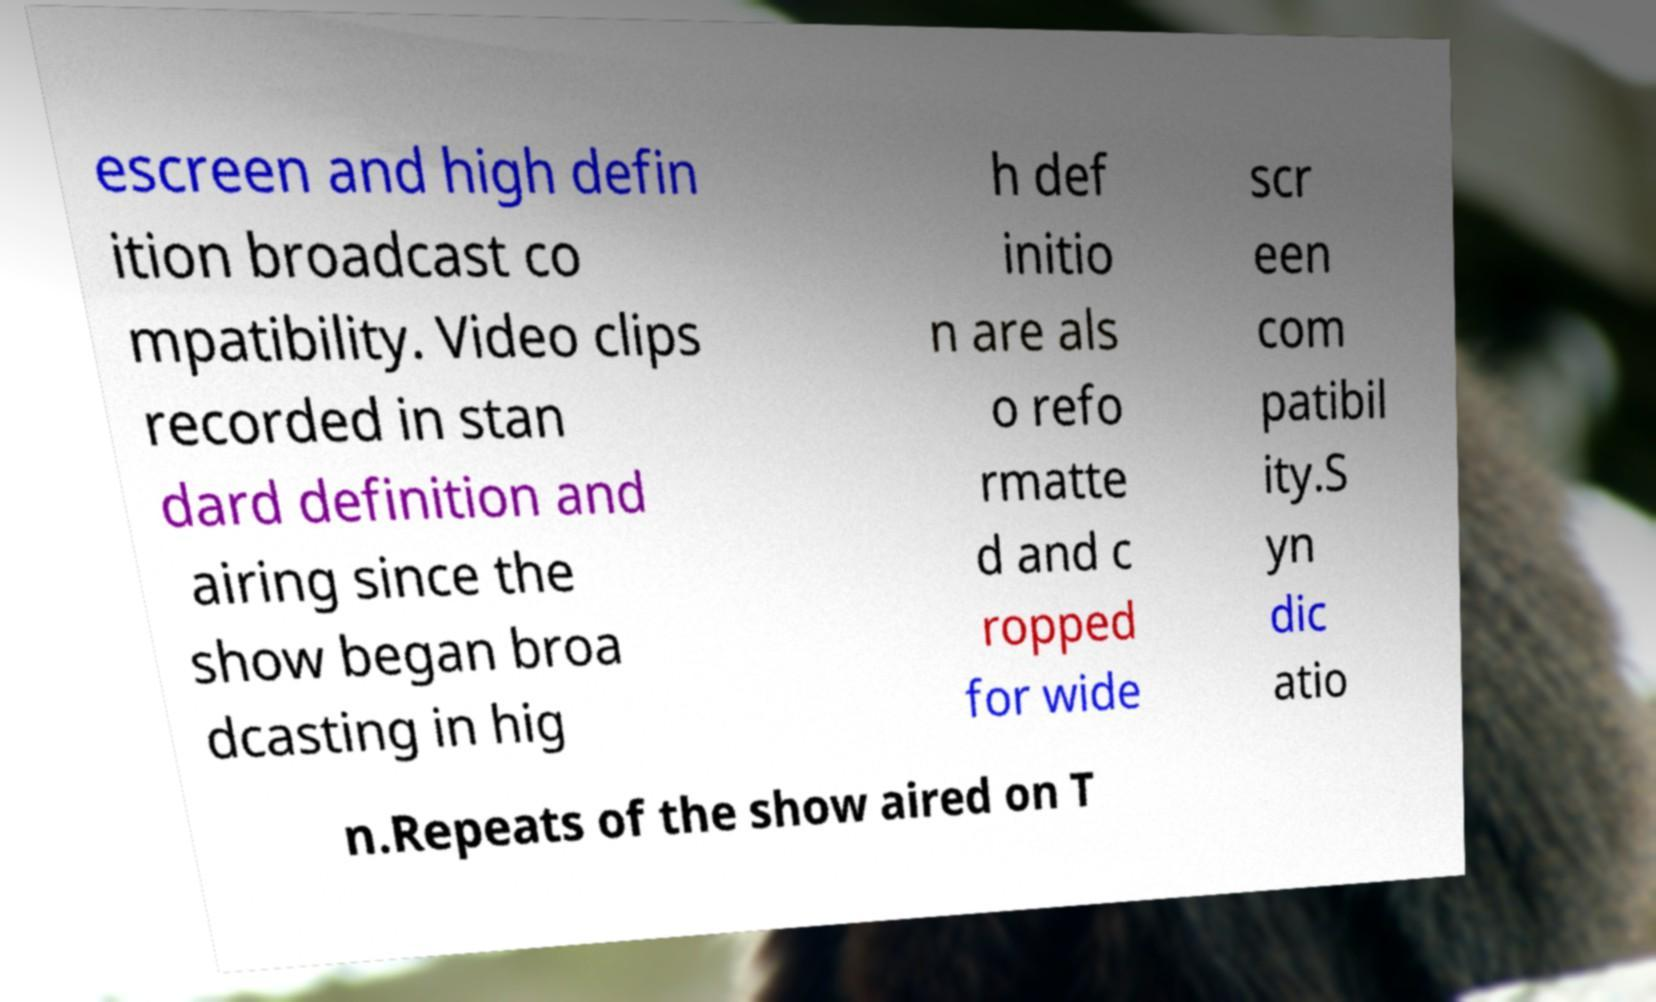Could you assist in decoding the text presented in this image and type it out clearly? escreen and high defin ition broadcast co mpatibility. Video clips recorded in stan dard definition and airing since the show began broa dcasting in hig h def initio n are als o refo rmatte d and c ropped for wide scr een com patibil ity.S yn dic atio n.Repeats of the show aired on T 